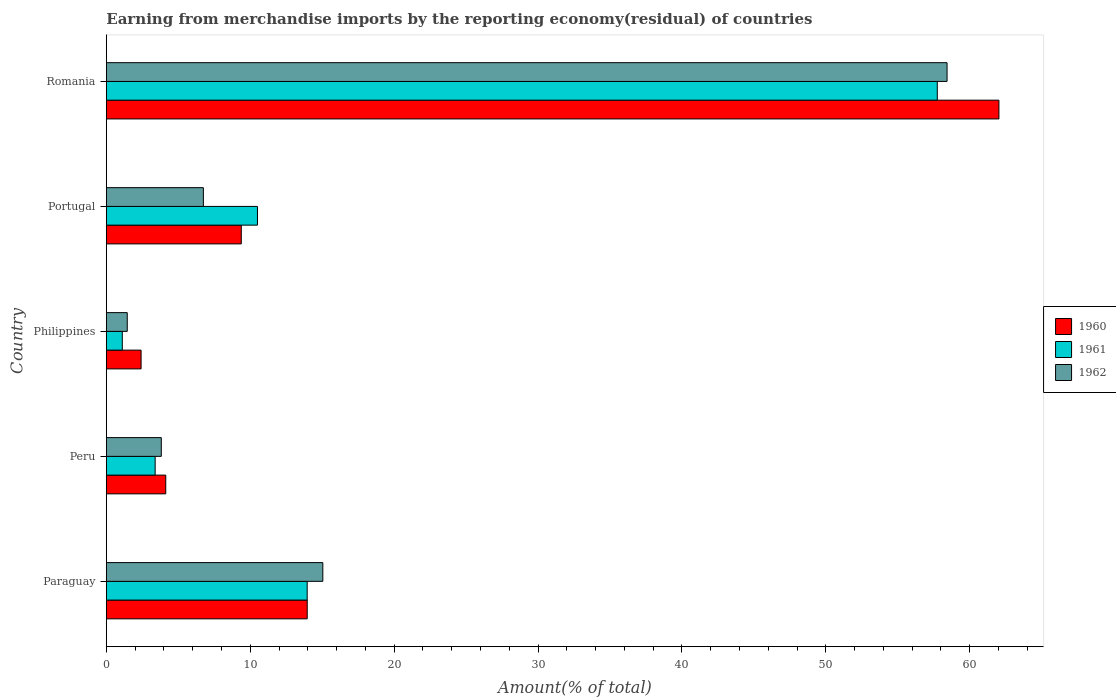How many different coloured bars are there?
Give a very brief answer. 3. How many groups of bars are there?
Ensure brevity in your answer.  5. Are the number of bars on each tick of the Y-axis equal?
Make the answer very short. Yes. How many bars are there on the 2nd tick from the bottom?
Offer a terse response. 3. In how many cases, is the number of bars for a given country not equal to the number of legend labels?
Ensure brevity in your answer.  0. What is the percentage of amount earned from merchandise imports in 1961 in Portugal?
Make the answer very short. 10.5. Across all countries, what is the maximum percentage of amount earned from merchandise imports in 1961?
Offer a very short reply. 57.75. Across all countries, what is the minimum percentage of amount earned from merchandise imports in 1961?
Your answer should be very brief. 1.11. In which country was the percentage of amount earned from merchandise imports in 1962 maximum?
Your answer should be very brief. Romania. In which country was the percentage of amount earned from merchandise imports in 1961 minimum?
Your response must be concise. Philippines. What is the total percentage of amount earned from merchandise imports in 1960 in the graph?
Your answer should be compact. 91.91. What is the difference between the percentage of amount earned from merchandise imports in 1961 in Portugal and that in Romania?
Offer a terse response. -47.24. What is the difference between the percentage of amount earned from merchandise imports in 1962 in Peru and the percentage of amount earned from merchandise imports in 1961 in Philippines?
Make the answer very short. 2.71. What is the average percentage of amount earned from merchandise imports in 1960 per country?
Provide a succinct answer. 18.38. What is the difference between the percentage of amount earned from merchandise imports in 1960 and percentage of amount earned from merchandise imports in 1961 in Paraguay?
Ensure brevity in your answer.  0. In how many countries, is the percentage of amount earned from merchandise imports in 1962 greater than 40 %?
Your answer should be very brief. 1. What is the ratio of the percentage of amount earned from merchandise imports in 1961 in Paraguay to that in Portugal?
Provide a succinct answer. 1.33. Is the percentage of amount earned from merchandise imports in 1960 in Peru less than that in Romania?
Provide a succinct answer. Yes. Is the difference between the percentage of amount earned from merchandise imports in 1960 in Paraguay and Peru greater than the difference between the percentage of amount earned from merchandise imports in 1961 in Paraguay and Peru?
Your answer should be compact. No. What is the difference between the highest and the second highest percentage of amount earned from merchandise imports in 1960?
Your response must be concise. 48.07. What is the difference between the highest and the lowest percentage of amount earned from merchandise imports in 1962?
Your answer should be very brief. 56.97. What does the 3rd bar from the top in Paraguay represents?
Provide a short and direct response. 1960. Are the values on the major ticks of X-axis written in scientific E-notation?
Offer a terse response. No. Does the graph contain any zero values?
Your response must be concise. No. Does the graph contain grids?
Keep it short and to the point. No. Where does the legend appear in the graph?
Provide a succinct answer. Center right. How are the legend labels stacked?
Keep it short and to the point. Vertical. What is the title of the graph?
Give a very brief answer. Earning from merchandise imports by the reporting economy(residual) of countries. Does "2006" appear as one of the legend labels in the graph?
Offer a very short reply. No. What is the label or title of the X-axis?
Provide a short and direct response. Amount(% of total). What is the label or title of the Y-axis?
Provide a short and direct response. Country. What is the Amount(% of total) of 1960 in Paraguay?
Ensure brevity in your answer.  13.96. What is the Amount(% of total) in 1961 in Paraguay?
Your answer should be compact. 13.96. What is the Amount(% of total) in 1962 in Paraguay?
Offer a very short reply. 15.05. What is the Amount(% of total) in 1960 in Peru?
Keep it short and to the point. 4.13. What is the Amount(% of total) of 1961 in Peru?
Your response must be concise. 3.39. What is the Amount(% of total) of 1962 in Peru?
Offer a very short reply. 3.82. What is the Amount(% of total) of 1960 in Philippines?
Your answer should be very brief. 2.41. What is the Amount(% of total) in 1961 in Philippines?
Provide a succinct answer. 1.11. What is the Amount(% of total) in 1962 in Philippines?
Keep it short and to the point. 1.45. What is the Amount(% of total) of 1960 in Portugal?
Provide a short and direct response. 9.38. What is the Amount(% of total) of 1961 in Portugal?
Offer a terse response. 10.5. What is the Amount(% of total) in 1962 in Portugal?
Offer a terse response. 6.74. What is the Amount(% of total) in 1960 in Romania?
Give a very brief answer. 62.03. What is the Amount(% of total) of 1961 in Romania?
Give a very brief answer. 57.75. What is the Amount(% of total) of 1962 in Romania?
Your response must be concise. 58.43. Across all countries, what is the maximum Amount(% of total) of 1960?
Offer a terse response. 62.03. Across all countries, what is the maximum Amount(% of total) of 1961?
Provide a short and direct response. 57.75. Across all countries, what is the maximum Amount(% of total) in 1962?
Make the answer very short. 58.43. Across all countries, what is the minimum Amount(% of total) in 1960?
Provide a short and direct response. 2.41. Across all countries, what is the minimum Amount(% of total) in 1961?
Offer a very short reply. 1.11. Across all countries, what is the minimum Amount(% of total) of 1962?
Ensure brevity in your answer.  1.45. What is the total Amount(% of total) in 1960 in the graph?
Provide a short and direct response. 91.91. What is the total Amount(% of total) in 1961 in the graph?
Your answer should be compact. 86.71. What is the total Amount(% of total) of 1962 in the graph?
Your answer should be compact. 85.49. What is the difference between the Amount(% of total) in 1960 in Paraguay and that in Peru?
Offer a terse response. 9.83. What is the difference between the Amount(% of total) in 1961 in Paraguay and that in Peru?
Ensure brevity in your answer.  10.56. What is the difference between the Amount(% of total) in 1962 in Paraguay and that in Peru?
Offer a very short reply. 11.23. What is the difference between the Amount(% of total) in 1960 in Paraguay and that in Philippines?
Provide a short and direct response. 11.55. What is the difference between the Amount(% of total) in 1961 in Paraguay and that in Philippines?
Your answer should be very brief. 12.85. What is the difference between the Amount(% of total) in 1962 in Paraguay and that in Philippines?
Your answer should be compact. 13.59. What is the difference between the Amount(% of total) in 1960 in Paraguay and that in Portugal?
Ensure brevity in your answer.  4.58. What is the difference between the Amount(% of total) in 1961 in Paraguay and that in Portugal?
Offer a very short reply. 3.45. What is the difference between the Amount(% of total) in 1962 in Paraguay and that in Portugal?
Provide a succinct answer. 8.3. What is the difference between the Amount(% of total) in 1960 in Paraguay and that in Romania?
Your answer should be compact. -48.07. What is the difference between the Amount(% of total) of 1961 in Paraguay and that in Romania?
Keep it short and to the point. -43.79. What is the difference between the Amount(% of total) of 1962 in Paraguay and that in Romania?
Give a very brief answer. -43.38. What is the difference between the Amount(% of total) in 1960 in Peru and that in Philippines?
Provide a succinct answer. 1.71. What is the difference between the Amount(% of total) in 1961 in Peru and that in Philippines?
Keep it short and to the point. 2.28. What is the difference between the Amount(% of total) of 1962 in Peru and that in Philippines?
Offer a very short reply. 2.37. What is the difference between the Amount(% of total) in 1960 in Peru and that in Portugal?
Give a very brief answer. -5.25. What is the difference between the Amount(% of total) of 1961 in Peru and that in Portugal?
Ensure brevity in your answer.  -7.11. What is the difference between the Amount(% of total) in 1962 in Peru and that in Portugal?
Your answer should be very brief. -2.92. What is the difference between the Amount(% of total) in 1960 in Peru and that in Romania?
Offer a terse response. -57.9. What is the difference between the Amount(% of total) in 1961 in Peru and that in Romania?
Provide a succinct answer. -54.35. What is the difference between the Amount(% of total) in 1962 in Peru and that in Romania?
Your answer should be very brief. -54.61. What is the difference between the Amount(% of total) of 1960 in Philippines and that in Portugal?
Give a very brief answer. -6.96. What is the difference between the Amount(% of total) in 1961 in Philippines and that in Portugal?
Your answer should be compact. -9.39. What is the difference between the Amount(% of total) of 1962 in Philippines and that in Portugal?
Keep it short and to the point. -5.29. What is the difference between the Amount(% of total) of 1960 in Philippines and that in Romania?
Provide a succinct answer. -59.62. What is the difference between the Amount(% of total) of 1961 in Philippines and that in Romania?
Your answer should be very brief. -56.64. What is the difference between the Amount(% of total) of 1962 in Philippines and that in Romania?
Your answer should be very brief. -56.97. What is the difference between the Amount(% of total) of 1960 in Portugal and that in Romania?
Provide a succinct answer. -52.65. What is the difference between the Amount(% of total) of 1961 in Portugal and that in Romania?
Offer a very short reply. -47.24. What is the difference between the Amount(% of total) in 1962 in Portugal and that in Romania?
Provide a succinct answer. -51.68. What is the difference between the Amount(% of total) of 1960 in Paraguay and the Amount(% of total) of 1961 in Peru?
Your response must be concise. 10.57. What is the difference between the Amount(% of total) in 1960 in Paraguay and the Amount(% of total) in 1962 in Peru?
Keep it short and to the point. 10.14. What is the difference between the Amount(% of total) of 1961 in Paraguay and the Amount(% of total) of 1962 in Peru?
Provide a succinct answer. 10.14. What is the difference between the Amount(% of total) of 1960 in Paraguay and the Amount(% of total) of 1961 in Philippines?
Offer a very short reply. 12.85. What is the difference between the Amount(% of total) in 1960 in Paraguay and the Amount(% of total) in 1962 in Philippines?
Provide a succinct answer. 12.51. What is the difference between the Amount(% of total) in 1961 in Paraguay and the Amount(% of total) in 1962 in Philippines?
Make the answer very short. 12.5. What is the difference between the Amount(% of total) of 1960 in Paraguay and the Amount(% of total) of 1961 in Portugal?
Your response must be concise. 3.46. What is the difference between the Amount(% of total) in 1960 in Paraguay and the Amount(% of total) in 1962 in Portugal?
Provide a succinct answer. 7.22. What is the difference between the Amount(% of total) of 1961 in Paraguay and the Amount(% of total) of 1962 in Portugal?
Provide a succinct answer. 7.21. What is the difference between the Amount(% of total) in 1960 in Paraguay and the Amount(% of total) in 1961 in Romania?
Provide a succinct answer. -43.79. What is the difference between the Amount(% of total) in 1960 in Paraguay and the Amount(% of total) in 1962 in Romania?
Your answer should be compact. -44.47. What is the difference between the Amount(% of total) of 1961 in Paraguay and the Amount(% of total) of 1962 in Romania?
Give a very brief answer. -44.47. What is the difference between the Amount(% of total) of 1960 in Peru and the Amount(% of total) of 1961 in Philippines?
Give a very brief answer. 3.02. What is the difference between the Amount(% of total) in 1960 in Peru and the Amount(% of total) in 1962 in Philippines?
Provide a short and direct response. 2.68. What is the difference between the Amount(% of total) of 1961 in Peru and the Amount(% of total) of 1962 in Philippines?
Your answer should be compact. 1.94. What is the difference between the Amount(% of total) of 1960 in Peru and the Amount(% of total) of 1961 in Portugal?
Offer a terse response. -6.37. What is the difference between the Amount(% of total) in 1960 in Peru and the Amount(% of total) in 1962 in Portugal?
Keep it short and to the point. -2.62. What is the difference between the Amount(% of total) of 1961 in Peru and the Amount(% of total) of 1962 in Portugal?
Provide a succinct answer. -3.35. What is the difference between the Amount(% of total) in 1960 in Peru and the Amount(% of total) in 1961 in Romania?
Your answer should be very brief. -53.62. What is the difference between the Amount(% of total) in 1960 in Peru and the Amount(% of total) in 1962 in Romania?
Your response must be concise. -54.3. What is the difference between the Amount(% of total) of 1961 in Peru and the Amount(% of total) of 1962 in Romania?
Offer a terse response. -55.03. What is the difference between the Amount(% of total) of 1960 in Philippines and the Amount(% of total) of 1961 in Portugal?
Give a very brief answer. -8.09. What is the difference between the Amount(% of total) in 1960 in Philippines and the Amount(% of total) in 1962 in Portugal?
Keep it short and to the point. -4.33. What is the difference between the Amount(% of total) in 1961 in Philippines and the Amount(% of total) in 1962 in Portugal?
Offer a terse response. -5.63. What is the difference between the Amount(% of total) in 1960 in Philippines and the Amount(% of total) in 1961 in Romania?
Keep it short and to the point. -55.33. What is the difference between the Amount(% of total) of 1960 in Philippines and the Amount(% of total) of 1962 in Romania?
Offer a terse response. -56.01. What is the difference between the Amount(% of total) in 1961 in Philippines and the Amount(% of total) in 1962 in Romania?
Your response must be concise. -57.32. What is the difference between the Amount(% of total) of 1960 in Portugal and the Amount(% of total) of 1961 in Romania?
Provide a short and direct response. -48.37. What is the difference between the Amount(% of total) of 1960 in Portugal and the Amount(% of total) of 1962 in Romania?
Make the answer very short. -49.05. What is the difference between the Amount(% of total) of 1961 in Portugal and the Amount(% of total) of 1962 in Romania?
Provide a succinct answer. -47.92. What is the average Amount(% of total) of 1960 per country?
Your answer should be compact. 18.38. What is the average Amount(% of total) of 1961 per country?
Offer a terse response. 17.34. What is the average Amount(% of total) in 1962 per country?
Offer a very short reply. 17.1. What is the difference between the Amount(% of total) of 1960 and Amount(% of total) of 1961 in Paraguay?
Ensure brevity in your answer.  0. What is the difference between the Amount(% of total) in 1960 and Amount(% of total) in 1962 in Paraguay?
Keep it short and to the point. -1.09. What is the difference between the Amount(% of total) in 1961 and Amount(% of total) in 1962 in Paraguay?
Your answer should be compact. -1.09. What is the difference between the Amount(% of total) in 1960 and Amount(% of total) in 1961 in Peru?
Your response must be concise. 0.74. What is the difference between the Amount(% of total) in 1960 and Amount(% of total) in 1962 in Peru?
Your response must be concise. 0.31. What is the difference between the Amount(% of total) of 1961 and Amount(% of total) of 1962 in Peru?
Offer a terse response. -0.43. What is the difference between the Amount(% of total) of 1960 and Amount(% of total) of 1961 in Philippines?
Offer a terse response. 1.3. What is the difference between the Amount(% of total) in 1960 and Amount(% of total) in 1962 in Philippines?
Make the answer very short. 0.96. What is the difference between the Amount(% of total) of 1961 and Amount(% of total) of 1962 in Philippines?
Offer a very short reply. -0.34. What is the difference between the Amount(% of total) of 1960 and Amount(% of total) of 1961 in Portugal?
Give a very brief answer. -1.12. What is the difference between the Amount(% of total) of 1960 and Amount(% of total) of 1962 in Portugal?
Provide a short and direct response. 2.63. What is the difference between the Amount(% of total) of 1961 and Amount(% of total) of 1962 in Portugal?
Ensure brevity in your answer.  3.76. What is the difference between the Amount(% of total) of 1960 and Amount(% of total) of 1961 in Romania?
Give a very brief answer. 4.28. What is the difference between the Amount(% of total) in 1960 and Amount(% of total) in 1962 in Romania?
Make the answer very short. 3.6. What is the difference between the Amount(% of total) of 1961 and Amount(% of total) of 1962 in Romania?
Offer a very short reply. -0.68. What is the ratio of the Amount(% of total) of 1960 in Paraguay to that in Peru?
Offer a terse response. 3.38. What is the ratio of the Amount(% of total) in 1961 in Paraguay to that in Peru?
Make the answer very short. 4.11. What is the ratio of the Amount(% of total) in 1962 in Paraguay to that in Peru?
Give a very brief answer. 3.94. What is the ratio of the Amount(% of total) of 1960 in Paraguay to that in Philippines?
Offer a terse response. 5.78. What is the ratio of the Amount(% of total) in 1961 in Paraguay to that in Philippines?
Give a very brief answer. 12.58. What is the ratio of the Amount(% of total) in 1962 in Paraguay to that in Philippines?
Ensure brevity in your answer.  10.35. What is the ratio of the Amount(% of total) in 1960 in Paraguay to that in Portugal?
Offer a very short reply. 1.49. What is the ratio of the Amount(% of total) in 1961 in Paraguay to that in Portugal?
Your answer should be compact. 1.33. What is the ratio of the Amount(% of total) in 1962 in Paraguay to that in Portugal?
Keep it short and to the point. 2.23. What is the ratio of the Amount(% of total) of 1960 in Paraguay to that in Romania?
Make the answer very short. 0.23. What is the ratio of the Amount(% of total) in 1961 in Paraguay to that in Romania?
Keep it short and to the point. 0.24. What is the ratio of the Amount(% of total) of 1962 in Paraguay to that in Romania?
Ensure brevity in your answer.  0.26. What is the ratio of the Amount(% of total) in 1960 in Peru to that in Philippines?
Your response must be concise. 1.71. What is the ratio of the Amount(% of total) of 1961 in Peru to that in Philippines?
Give a very brief answer. 3.06. What is the ratio of the Amount(% of total) in 1962 in Peru to that in Philippines?
Give a very brief answer. 2.63. What is the ratio of the Amount(% of total) of 1960 in Peru to that in Portugal?
Ensure brevity in your answer.  0.44. What is the ratio of the Amount(% of total) of 1961 in Peru to that in Portugal?
Offer a terse response. 0.32. What is the ratio of the Amount(% of total) in 1962 in Peru to that in Portugal?
Keep it short and to the point. 0.57. What is the ratio of the Amount(% of total) in 1960 in Peru to that in Romania?
Your answer should be compact. 0.07. What is the ratio of the Amount(% of total) of 1961 in Peru to that in Romania?
Offer a very short reply. 0.06. What is the ratio of the Amount(% of total) of 1962 in Peru to that in Romania?
Keep it short and to the point. 0.07. What is the ratio of the Amount(% of total) in 1960 in Philippines to that in Portugal?
Provide a short and direct response. 0.26. What is the ratio of the Amount(% of total) of 1961 in Philippines to that in Portugal?
Provide a succinct answer. 0.11. What is the ratio of the Amount(% of total) of 1962 in Philippines to that in Portugal?
Your answer should be very brief. 0.22. What is the ratio of the Amount(% of total) in 1960 in Philippines to that in Romania?
Give a very brief answer. 0.04. What is the ratio of the Amount(% of total) of 1961 in Philippines to that in Romania?
Your response must be concise. 0.02. What is the ratio of the Amount(% of total) of 1962 in Philippines to that in Romania?
Provide a succinct answer. 0.02. What is the ratio of the Amount(% of total) in 1960 in Portugal to that in Romania?
Your answer should be compact. 0.15. What is the ratio of the Amount(% of total) of 1961 in Portugal to that in Romania?
Provide a succinct answer. 0.18. What is the ratio of the Amount(% of total) in 1962 in Portugal to that in Romania?
Provide a succinct answer. 0.12. What is the difference between the highest and the second highest Amount(% of total) of 1960?
Your response must be concise. 48.07. What is the difference between the highest and the second highest Amount(% of total) of 1961?
Provide a succinct answer. 43.79. What is the difference between the highest and the second highest Amount(% of total) of 1962?
Ensure brevity in your answer.  43.38. What is the difference between the highest and the lowest Amount(% of total) of 1960?
Your response must be concise. 59.62. What is the difference between the highest and the lowest Amount(% of total) in 1961?
Provide a succinct answer. 56.64. What is the difference between the highest and the lowest Amount(% of total) in 1962?
Offer a terse response. 56.97. 